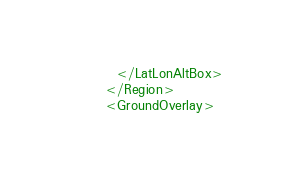<code> <loc_0><loc_0><loc_500><loc_500><_XML_>	      </LatLonAltBox>
	    </Region>
	    <GroundOverlay></code> 